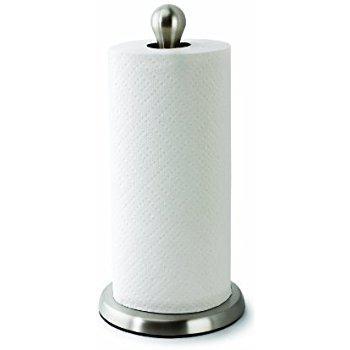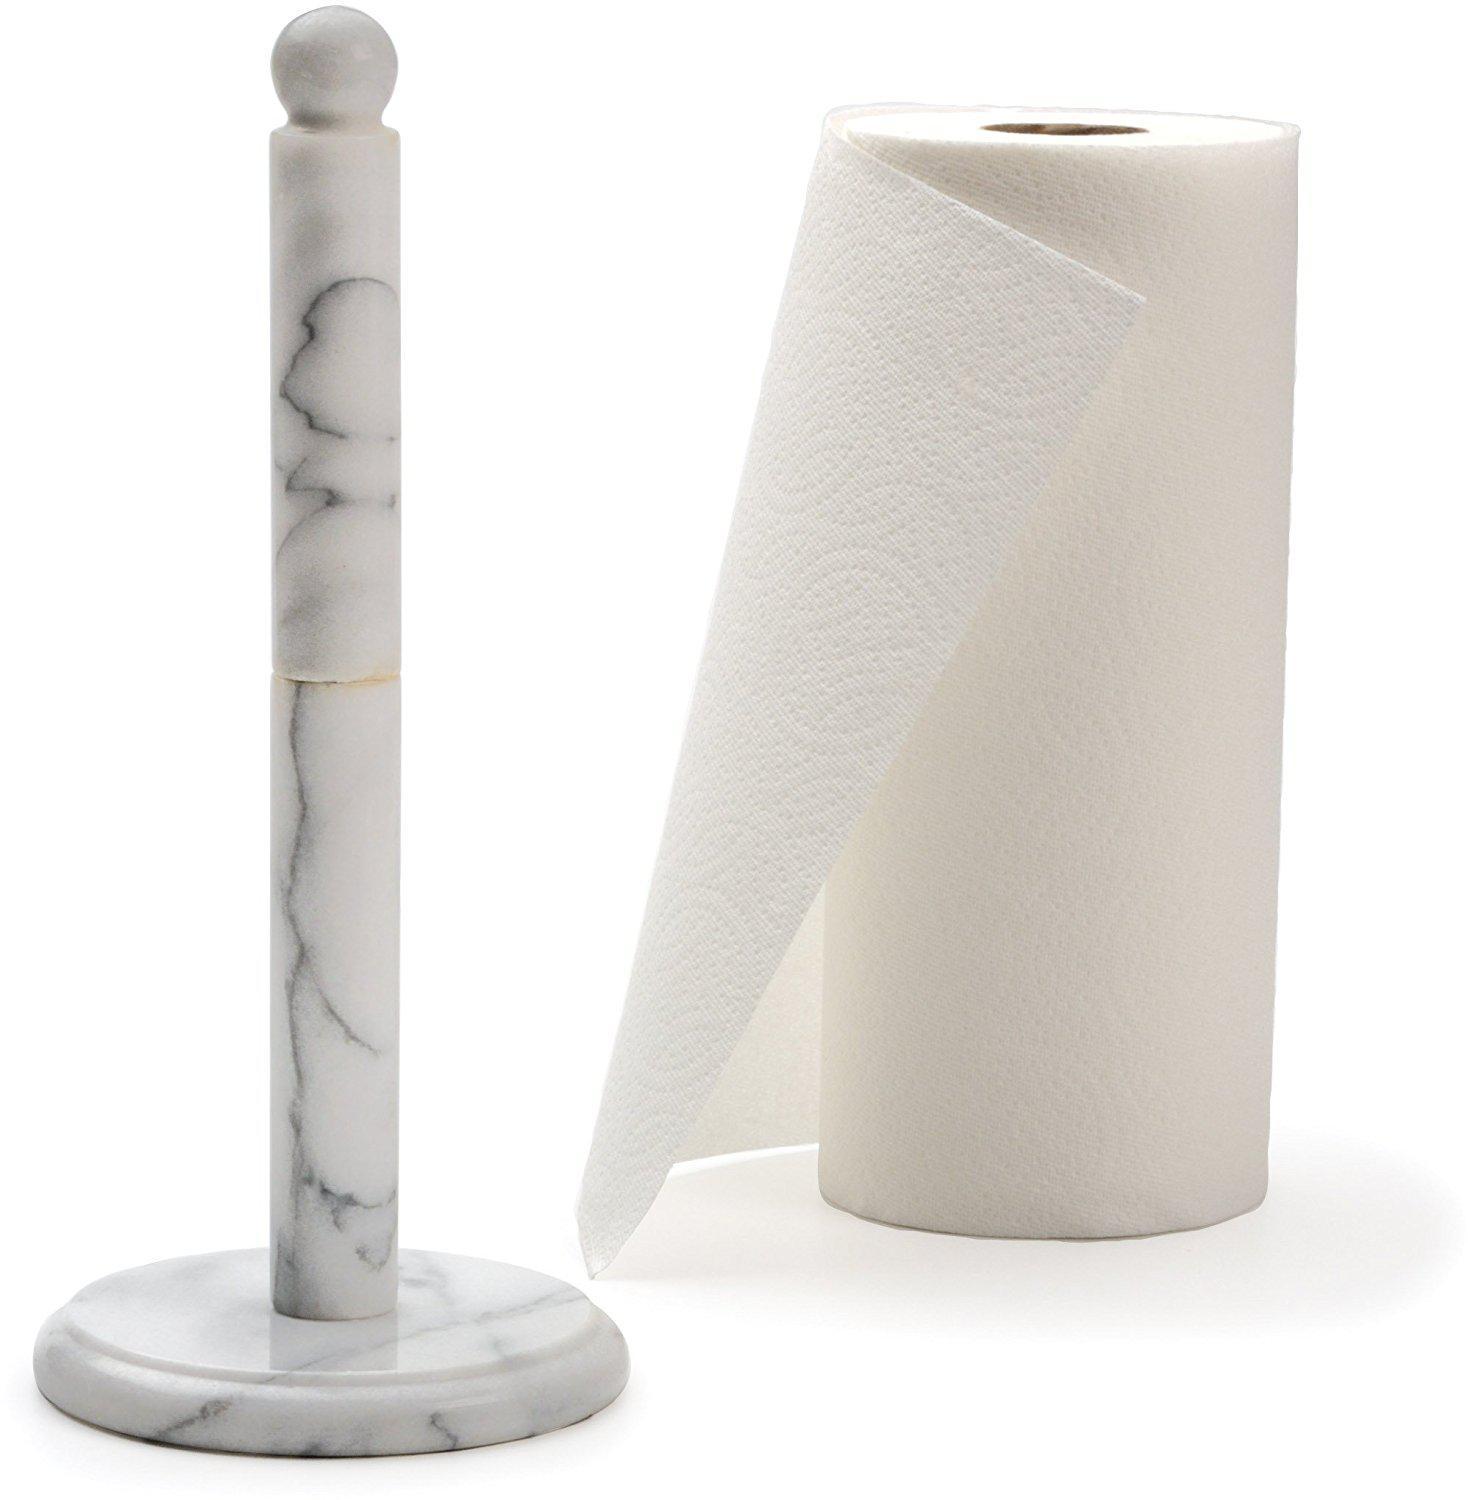The first image is the image on the left, the second image is the image on the right. Analyze the images presented: Is the assertion "One image shows a towel roll without a stand and without any sheet unfurled." valid? Answer yes or no. No. The first image is the image on the left, the second image is the image on the right. For the images displayed, is the sentence "Only one of the paper towel rolls is on the paper towel holder." factually correct? Answer yes or no. Yes. 